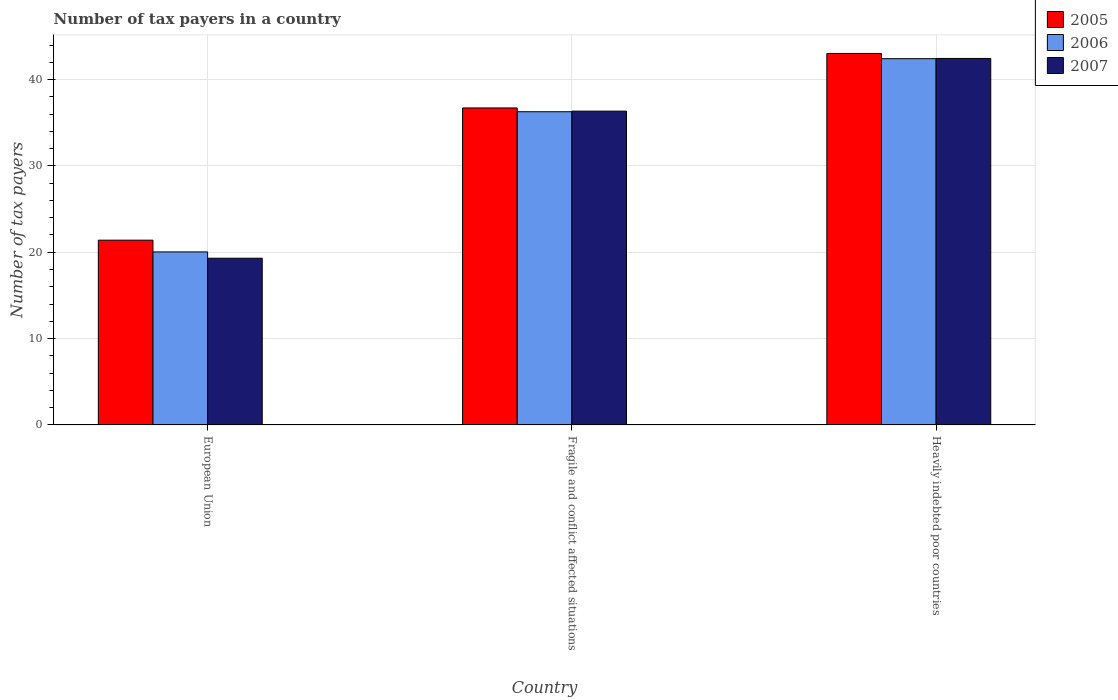Are the number of bars per tick equal to the number of legend labels?
Ensure brevity in your answer.  Yes. Are the number of bars on each tick of the X-axis equal?
Provide a short and direct response. Yes. How many bars are there on the 1st tick from the right?
Your answer should be very brief. 3. What is the label of the 1st group of bars from the left?
Your answer should be very brief. European Union. In how many cases, is the number of bars for a given country not equal to the number of legend labels?
Your response must be concise. 0. What is the number of tax payers in in 2006 in Fragile and conflict affected situations?
Offer a terse response. 36.28. Across all countries, what is the maximum number of tax payers in in 2006?
Your answer should be very brief. 42.42. Across all countries, what is the minimum number of tax payers in in 2006?
Keep it short and to the point. 20.04. In which country was the number of tax payers in in 2005 maximum?
Ensure brevity in your answer.  Heavily indebted poor countries. In which country was the number of tax payers in in 2007 minimum?
Offer a very short reply. European Union. What is the total number of tax payers in in 2007 in the graph?
Your answer should be compact. 98.1. What is the difference between the number of tax payers in in 2007 in Fragile and conflict affected situations and that in Heavily indebted poor countries?
Your response must be concise. -6.1. What is the difference between the number of tax payers in in 2005 in Heavily indebted poor countries and the number of tax payers in in 2006 in Fragile and conflict affected situations?
Your answer should be compact. 6.75. What is the average number of tax payers in in 2006 per country?
Your response must be concise. 32.91. What is the difference between the number of tax payers in of/in 2005 and number of tax payers in of/in 2007 in Fragile and conflict affected situations?
Make the answer very short. 0.37. In how many countries, is the number of tax payers in in 2006 greater than 34?
Offer a very short reply. 2. What is the ratio of the number of tax payers in in 2006 in Fragile and conflict affected situations to that in Heavily indebted poor countries?
Your answer should be compact. 0.86. Is the number of tax payers in in 2007 in European Union less than that in Heavily indebted poor countries?
Your answer should be very brief. Yes. What is the difference between the highest and the second highest number of tax payers in in 2007?
Your answer should be very brief. 23.14. What is the difference between the highest and the lowest number of tax payers in in 2007?
Your response must be concise. 23.14. In how many countries, is the number of tax payers in in 2007 greater than the average number of tax payers in in 2007 taken over all countries?
Offer a terse response. 2. What does the 2nd bar from the left in Fragile and conflict affected situations represents?
Make the answer very short. 2006. Is it the case that in every country, the sum of the number of tax payers in in 2005 and number of tax payers in in 2007 is greater than the number of tax payers in in 2006?
Your answer should be very brief. Yes. How many bars are there?
Your answer should be very brief. 9. What is the difference between two consecutive major ticks on the Y-axis?
Offer a very short reply. 10. Where does the legend appear in the graph?
Your answer should be compact. Top right. How many legend labels are there?
Your answer should be very brief. 3. How are the legend labels stacked?
Provide a short and direct response. Vertical. What is the title of the graph?
Your answer should be compact. Number of tax payers in a country. Does "2012" appear as one of the legend labels in the graph?
Provide a succinct answer. No. What is the label or title of the Y-axis?
Your answer should be very brief. Number of tax payers. What is the Number of tax payers of 2005 in European Union?
Your response must be concise. 21.4. What is the Number of tax payers in 2006 in European Union?
Keep it short and to the point. 20.04. What is the Number of tax payers of 2007 in European Union?
Provide a short and direct response. 19.31. What is the Number of tax payers of 2005 in Fragile and conflict affected situations?
Make the answer very short. 36.71. What is the Number of tax payers in 2006 in Fragile and conflict affected situations?
Offer a very short reply. 36.28. What is the Number of tax payers of 2007 in Fragile and conflict affected situations?
Your response must be concise. 36.34. What is the Number of tax payers of 2005 in Heavily indebted poor countries?
Keep it short and to the point. 43.03. What is the Number of tax payers in 2006 in Heavily indebted poor countries?
Give a very brief answer. 42.42. What is the Number of tax payers in 2007 in Heavily indebted poor countries?
Your answer should be compact. 42.45. Across all countries, what is the maximum Number of tax payers in 2005?
Provide a succinct answer. 43.03. Across all countries, what is the maximum Number of tax payers in 2006?
Provide a succinct answer. 42.42. Across all countries, what is the maximum Number of tax payers of 2007?
Your response must be concise. 42.45. Across all countries, what is the minimum Number of tax payers of 2005?
Provide a succinct answer. 21.4. Across all countries, what is the minimum Number of tax payers in 2006?
Make the answer very short. 20.04. Across all countries, what is the minimum Number of tax payers in 2007?
Keep it short and to the point. 19.31. What is the total Number of tax payers in 2005 in the graph?
Your answer should be very brief. 101.14. What is the total Number of tax payers of 2006 in the graph?
Your response must be concise. 98.74. What is the total Number of tax payers in 2007 in the graph?
Offer a very short reply. 98.1. What is the difference between the Number of tax payers in 2005 in European Union and that in Fragile and conflict affected situations?
Provide a short and direct response. -15.31. What is the difference between the Number of tax payers in 2006 in European Union and that in Fragile and conflict affected situations?
Your answer should be compact. -16.24. What is the difference between the Number of tax payers in 2007 in European Union and that in Fragile and conflict affected situations?
Provide a succinct answer. -17.04. What is the difference between the Number of tax payers of 2005 in European Union and that in Heavily indebted poor countries?
Make the answer very short. -21.63. What is the difference between the Number of tax payers of 2006 in European Union and that in Heavily indebted poor countries?
Your answer should be compact. -22.38. What is the difference between the Number of tax payers in 2007 in European Union and that in Heavily indebted poor countries?
Keep it short and to the point. -23.14. What is the difference between the Number of tax payers of 2005 in Fragile and conflict affected situations and that in Heavily indebted poor countries?
Ensure brevity in your answer.  -6.31. What is the difference between the Number of tax payers in 2006 in Fragile and conflict affected situations and that in Heavily indebted poor countries?
Provide a succinct answer. -6.15. What is the difference between the Number of tax payers in 2007 in Fragile and conflict affected situations and that in Heavily indebted poor countries?
Your answer should be compact. -6.1. What is the difference between the Number of tax payers of 2005 in European Union and the Number of tax payers of 2006 in Fragile and conflict affected situations?
Offer a very short reply. -14.88. What is the difference between the Number of tax payers of 2005 in European Union and the Number of tax payers of 2007 in Fragile and conflict affected situations?
Offer a very short reply. -14.94. What is the difference between the Number of tax payers in 2006 in European Union and the Number of tax payers in 2007 in Fragile and conflict affected situations?
Make the answer very short. -16.31. What is the difference between the Number of tax payers of 2005 in European Union and the Number of tax payers of 2006 in Heavily indebted poor countries?
Give a very brief answer. -21.02. What is the difference between the Number of tax payers of 2005 in European Union and the Number of tax payers of 2007 in Heavily indebted poor countries?
Provide a short and direct response. -21.05. What is the difference between the Number of tax payers of 2006 in European Union and the Number of tax payers of 2007 in Heavily indebted poor countries?
Provide a short and direct response. -22.41. What is the difference between the Number of tax payers of 2005 in Fragile and conflict affected situations and the Number of tax payers of 2006 in Heavily indebted poor countries?
Provide a short and direct response. -5.71. What is the difference between the Number of tax payers of 2005 in Fragile and conflict affected situations and the Number of tax payers of 2007 in Heavily indebted poor countries?
Your answer should be compact. -5.73. What is the difference between the Number of tax payers of 2006 in Fragile and conflict affected situations and the Number of tax payers of 2007 in Heavily indebted poor countries?
Ensure brevity in your answer.  -6.17. What is the average Number of tax payers in 2005 per country?
Offer a terse response. 33.71. What is the average Number of tax payers in 2006 per country?
Your answer should be very brief. 32.91. What is the average Number of tax payers of 2007 per country?
Offer a very short reply. 32.7. What is the difference between the Number of tax payers in 2005 and Number of tax payers in 2006 in European Union?
Provide a short and direct response. 1.36. What is the difference between the Number of tax payers in 2005 and Number of tax payers in 2007 in European Union?
Make the answer very short. 2.09. What is the difference between the Number of tax payers of 2006 and Number of tax payers of 2007 in European Union?
Provide a short and direct response. 0.73. What is the difference between the Number of tax payers in 2005 and Number of tax payers in 2006 in Fragile and conflict affected situations?
Provide a short and direct response. 0.44. What is the difference between the Number of tax payers of 2005 and Number of tax payers of 2007 in Fragile and conflict affected situations?
Provide a succinct answer. 0.37. What is the difference between the Number of tax payers in 2006 and Number of tax payers in 2007 in Fragile and conflict affected situations?
Offer a very short reply. -0.07. What is the difference between the Number of tax payers in 2005 and Number of tax payers in 2006 in Heavily indebted poor countries?
Keep it short and to the point. 0.61. What is the difference between the Number of tax payers of 2005 and Number of tax payers of 2007 in Heavily indebted poor countries?
Your answer should be compact. 0.58. What is the difference between the Number of tax payers of 2006 and Number of tax payers of 2007 in Heavily indebted poor countries?
Your answer should be compact. -0.03. What is the ratio of the Number of tax payers in 2005 in European Union to that in Fragile and conflict affected situations?
Make the answer very short. 0.58. What is the ratio of the Number of tax payers in 2006 in European Union to that in Fragile and conflict affected situations?
Offer a terse response. 0.55. What is the ratio of the Number of tax payers of 2007 in European Union to that in Fragile and conflict affected situations?
Provide a succinct answer. 0.53. What is the ratio of the Number of tax payers in 2005 in European Union to that in Heavily indebted poor countries?
Your answer should be very brief. 0.5. What is the ratio of the Number of tax payers in 2006 in European Union to that in Heavily indebted poor countries?
Offer a terse response. 0.47. What is the ratio of the Number of tax payers of 2007 in European Union to that in Heavily indebted poor countries?
Provide a short and direct response. 0.45. What is the ratio of the Number of tax payers of 2005 in Fragile and conflict affected situations to that in Heavily indebted poor countries?
Provide a succinct answer. 0.85. What is the ratio of the Number of tax payers in 2006 in Fragile and conflict affected situations to that in Heavily indebted poor countries?
Provide a short and direct response. 0.86. What is the ratio of the Number of tax payers in 2007 in Fragile and conflict affected situations to that in Heavily indebted poor countries?
Give a very brief answer. 0.86. What is the difference between the highest and the second highest Number of tax payers of 2005?
Make the answer very short. 6.31. What is the difference between the highest and the second highest Number of tax payers in 2006?
Offer a very short reply. 6.15. What is the difference between the highest and the second highest Number of tax payers of 2007?
Keep it short and to the point. 6.1. What is the difference between the highest and the lowest Number of tax payers in 2005?
Your answer should be very brief. 21.63. What is the difference between the highest and the lowest Number of tax payers in 2006?
Give a very brief answer. 22.38. What is the difference between the highest and the lowest Number of tax payers in 2007?
Ensure brevity in your answer.  23.14. 